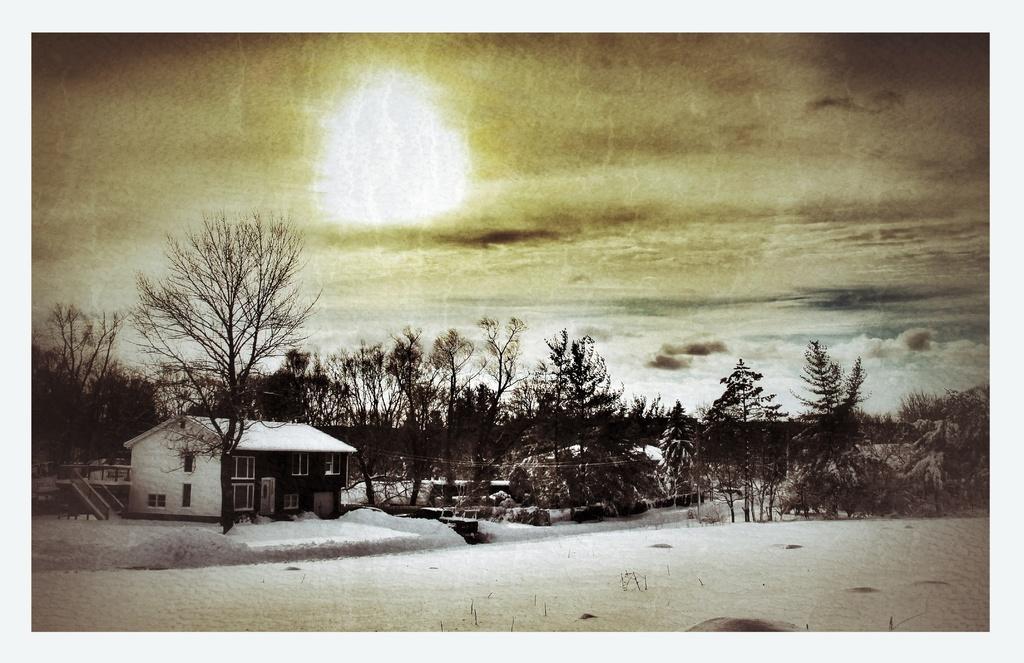Can you describe this image briefly? Here, we can see a photo, there is a house and there are some trees, at the top there is a sky in the photo. 